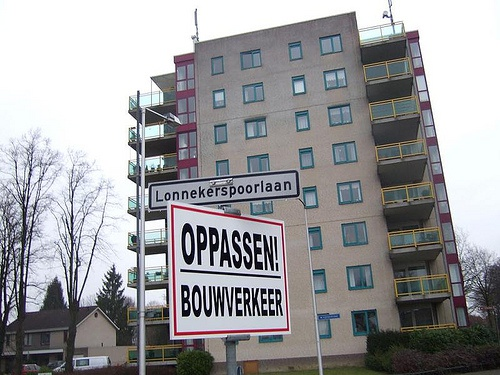Describe the objects in this image and their specific colors. I can see truck in white, darkgray, gray, and lightgray tones, car in white, gray, black, maroon, and purple tones, car in white, black, and gray tones, potted plant in white, purple, and black tones, and chair in white, gray, and black tones in this image. 